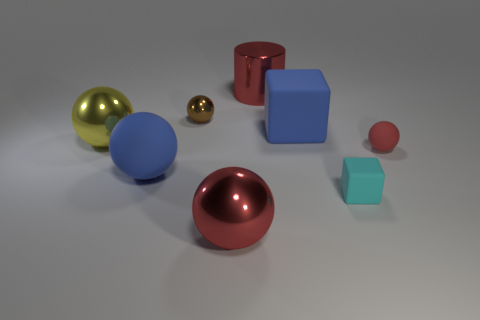Can you tell me what shapes and colors you see in this image? Certainly, I see a variety of geometric shapes including spheres, cylinders, and cubes. The colors present are red, blue, gold, and what seems to be a teal or light blue shade. Thank you! Which one appears to be the largest object? The largest object in the image appears to be the blue cube on the right. 